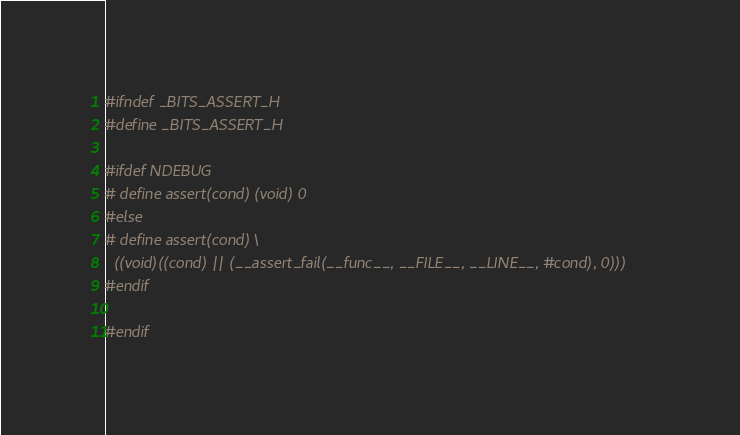<code> <loc_0><loc_0><loc_500><loc_500><_C_>#ifndef _BITS_ASSERT_H
#define _BITS_ASSERT_H

#ifdef NDEBUG
# define assert(cond) (void) 0
#else
# define assert(cond) \
  ((void)((cond) || (__assert_fail(__func__, __FILE__, __LINE__, #cond), 0)))
#endif

#endif
</code> 